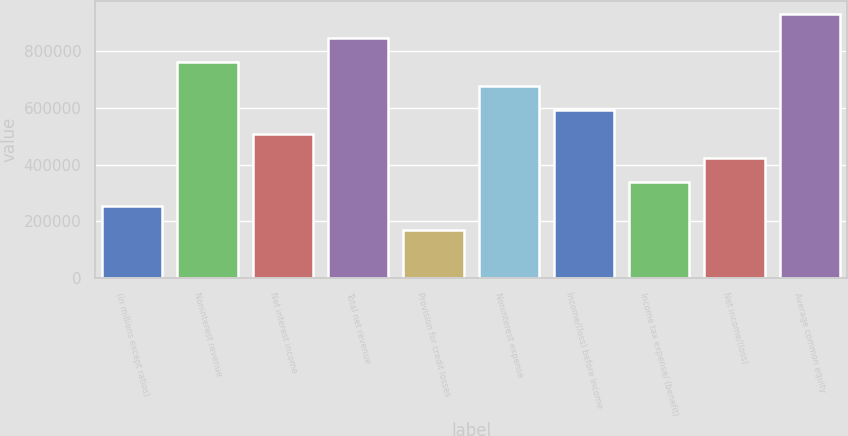Convert chart. <chart><loc_0><loc_0><loc_500><loc_500><bar_chart><fcel>(in millions except ratios)<fcel>Noninterest revenue<fcel>Net interest income<fcel>Total net revenue<fcel>Provision for credit losses<fcel>Noninterest expense<fcel>Income/(loss) before income<fcel>Income tax expense/ (benefit)<fcel>Net income/(loss)<fcel>Average common equity<nl><fcel>253540<fcel>760587<fcel>507064<fcel>845095<fcel>169033<fcel>676079<fcel>591572<fcel>338048<fcel>422556<fcel>929603<nl></chart> 